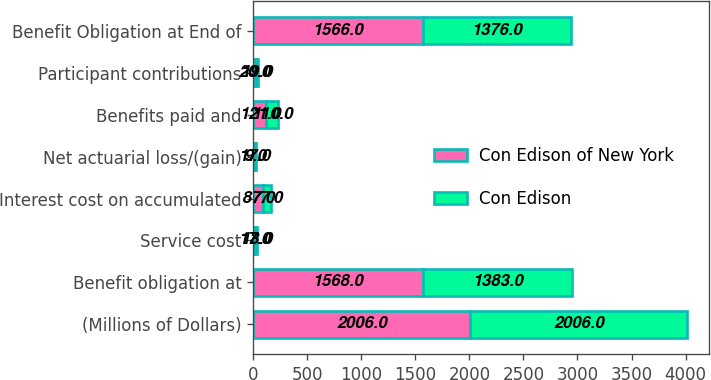Convert chart to OTSL. <chart><loc_0><loc_0><loc_500><loc_500><stacked_bar_chart><ecel><fcel>(Millions of Dollars)<fcel>Benefit obligation at<fcel>Service cost<fcel>Interest cost on accumulated<fcel>Net actuarial loss/(gain)<fcel>Benefits paid and<fcel>Participant contributions<fcel>Benefit Obligation at End of<nl><fcel>Con Edison of New York<fcel>2006<fcel>1568<fcel>17<fcel>87<fcel>17<fcel>121<fcel>20<fcel>1566<nl><fcel>Con Edison<fcel>2006<fcel>1383<fcel>13<fcel>77<fcel>9<fcel>110<fcel>19<fcel>1376<nl></chart> 